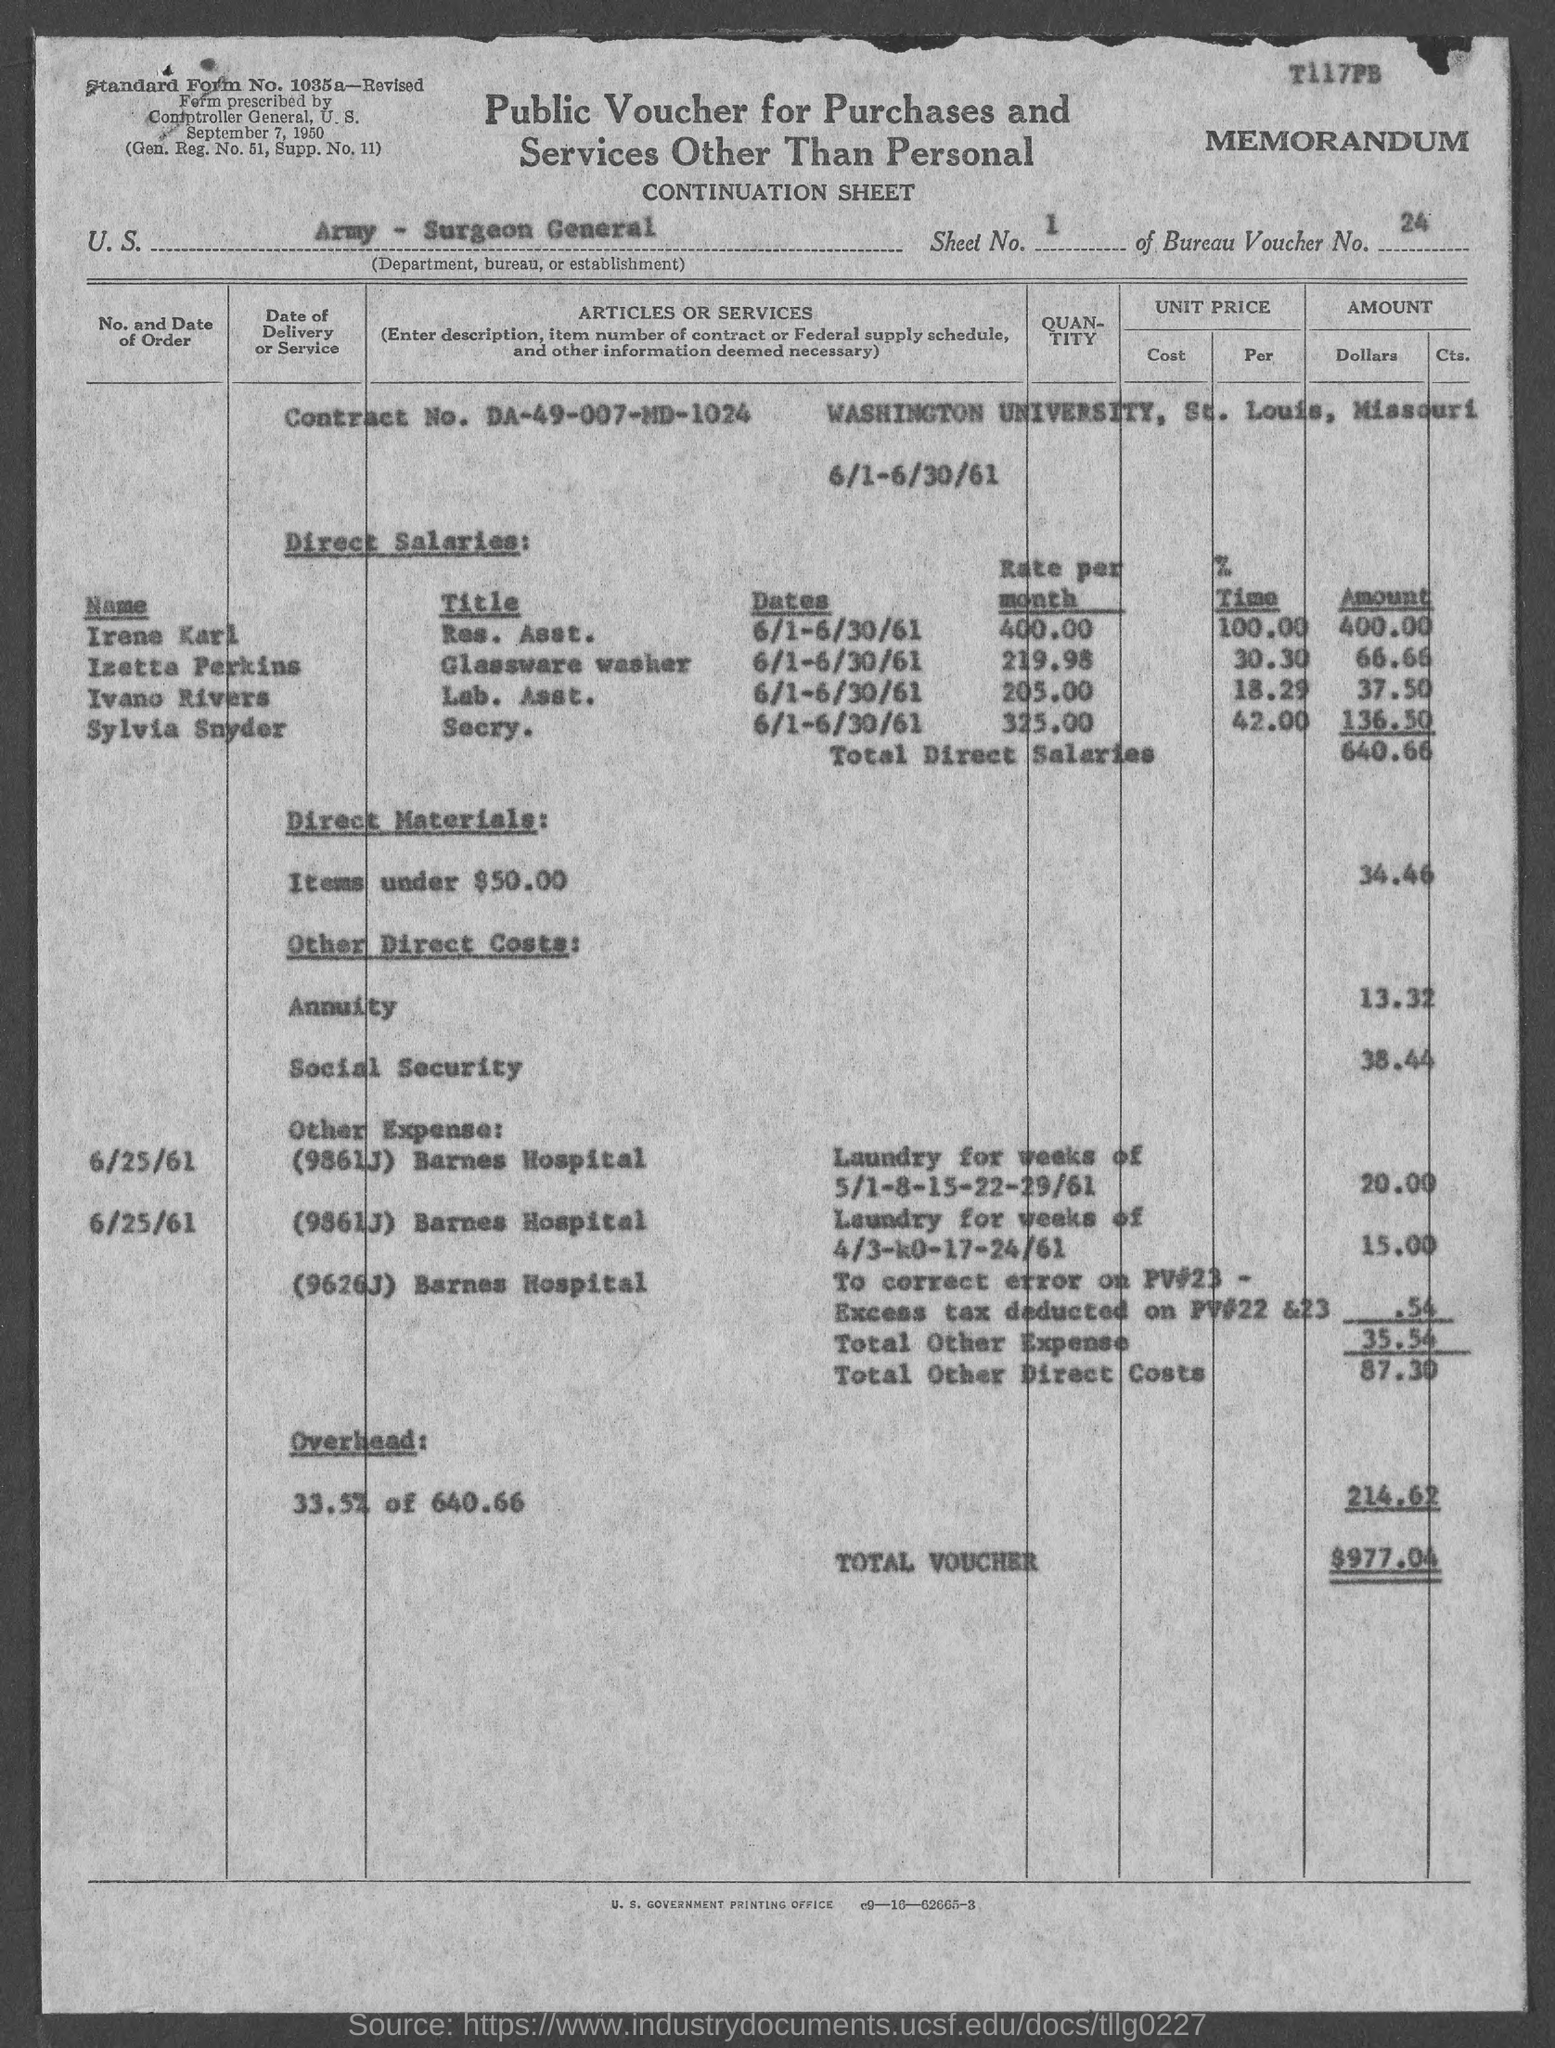Indicate a few pertinent items in this graphic. The contract number is DA-49-007-MD-1024. Irene Karl is a Resident Assistant at [name of residence or location]. The title of Izetta Perkins is Glassware Washer. Washington University, located in the state of Missouri. Sylvia Snyder is the Secretary. 